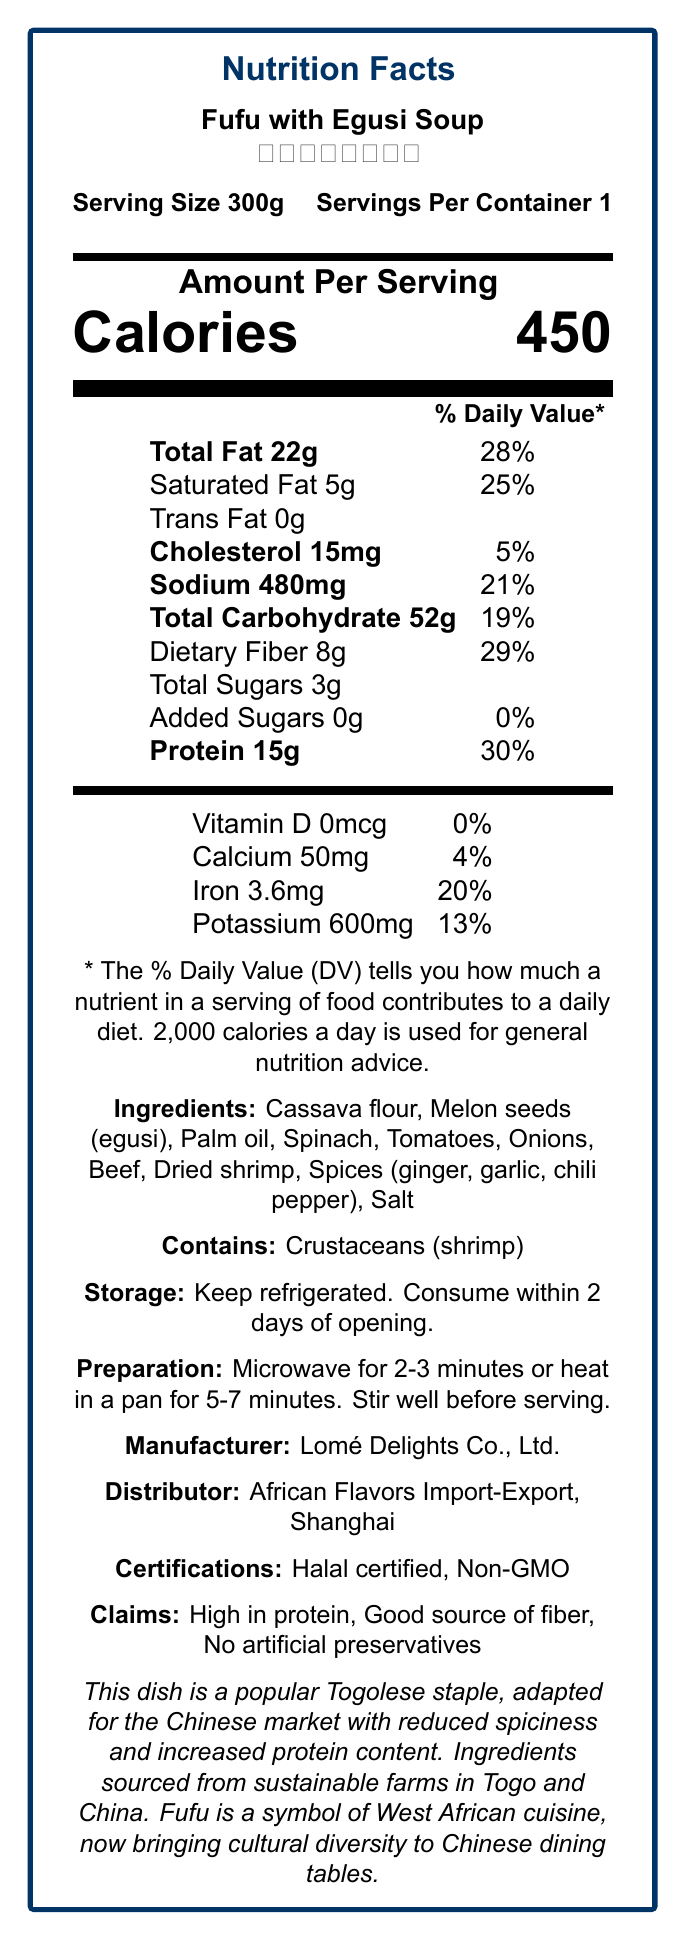what is the serving size of Fufu with Egusi Soup? The serving size is clearly mentioned at the top of the Nutrition Facts Label as "Serving Size 300g".
Answer: 300g how many grams of dietary fiber does one serving contain? The document specifies "Dietary Fiber 8g".
Answer: 8g what is the calorie count per serving? The document states the amount per serving as "Calories 450".
Answer: 450 calories which ingredient is specifically mentioned as an allergen? The allergen information states "Contains: Crustaceans (shrimp)".
Answer: Shrimp how should the dish be stored after opening? The storage instructions indicate "Keep refrigerated. Consume within 2 days of opening."
Answer: Keep refrigerated, Consume within 2 days of opening what is the amount of protein in one serving? The protein amount for one serving is specified as 15g.
Answer: 15g what percentage of the daily value for protein does one serving provide? The percentage of the daily value for protein is 30%, listed next to "Protein 15g".
Answer: 30% what certifications does this product have? A. Halal certified B. Non-GMO C. Organic D. Both A and B The product is listed as being "Halal certified" and "Non-GMO".
Answer: D. Both A and B how many servings are there per container? A. 1 B. 2 C. 3 D. 4 The document states "Servings Per Container 1".
Answer: A. 1 is there any added sugar in this dish? The document mentions "Added Sugars 0g" with a daily value contribution of 0%.
Answer: No can the dish be prepared using a microwave? The preparation instructions include "Microwave for 2-3 minutes".
Answer: Yes does the document provide any sustainability information regarding the ingredients? The additional info mentions "Ingredients sourced from sustainable farms in Togo and China."
Answer: Yes summarize the Nutrition Facts Label for Fufu with Egusi Soup. This summary encapsulates all the vital nutritional information and other relevant details provided in the Nutrition Facts Label.
Answer: The Nutrition Facts Label for "Fufu with Egusi Soup (托哥福福和瓜子汤)" indicates a serving size of 300g, with 450 calories per serving. It contains 22g of total fat (28% DV), including 5g of saturated fat (25% DV), and has no trans fat. It includes 15mg of cholesterol (5% DV) and 480mg of sodium (21% DV). The dish provides 52g of total carbohydrates (19% DV), including 8g of dietary fiber (29% DV) and 3g of total sugars with no added sugars. It is high in protein, offering 15g (30% DV). The product also contains essential vitamins and minerals like calcium (4% DV), iron (20% DV), and potassium (13% DV). Ingredients include cassava flour, melon seeds (egusi), palm oil, spinach, and others. It contains crustaceans (shrimp) as an allergen and has Halal and Non-GMO certifications. The dish should be refrigerated and consumed within 2 days of opening. where can you buy this dish in China? The document does not provide specific retail locations where this product can be purchased in China.
Answer: Cannot be determined 